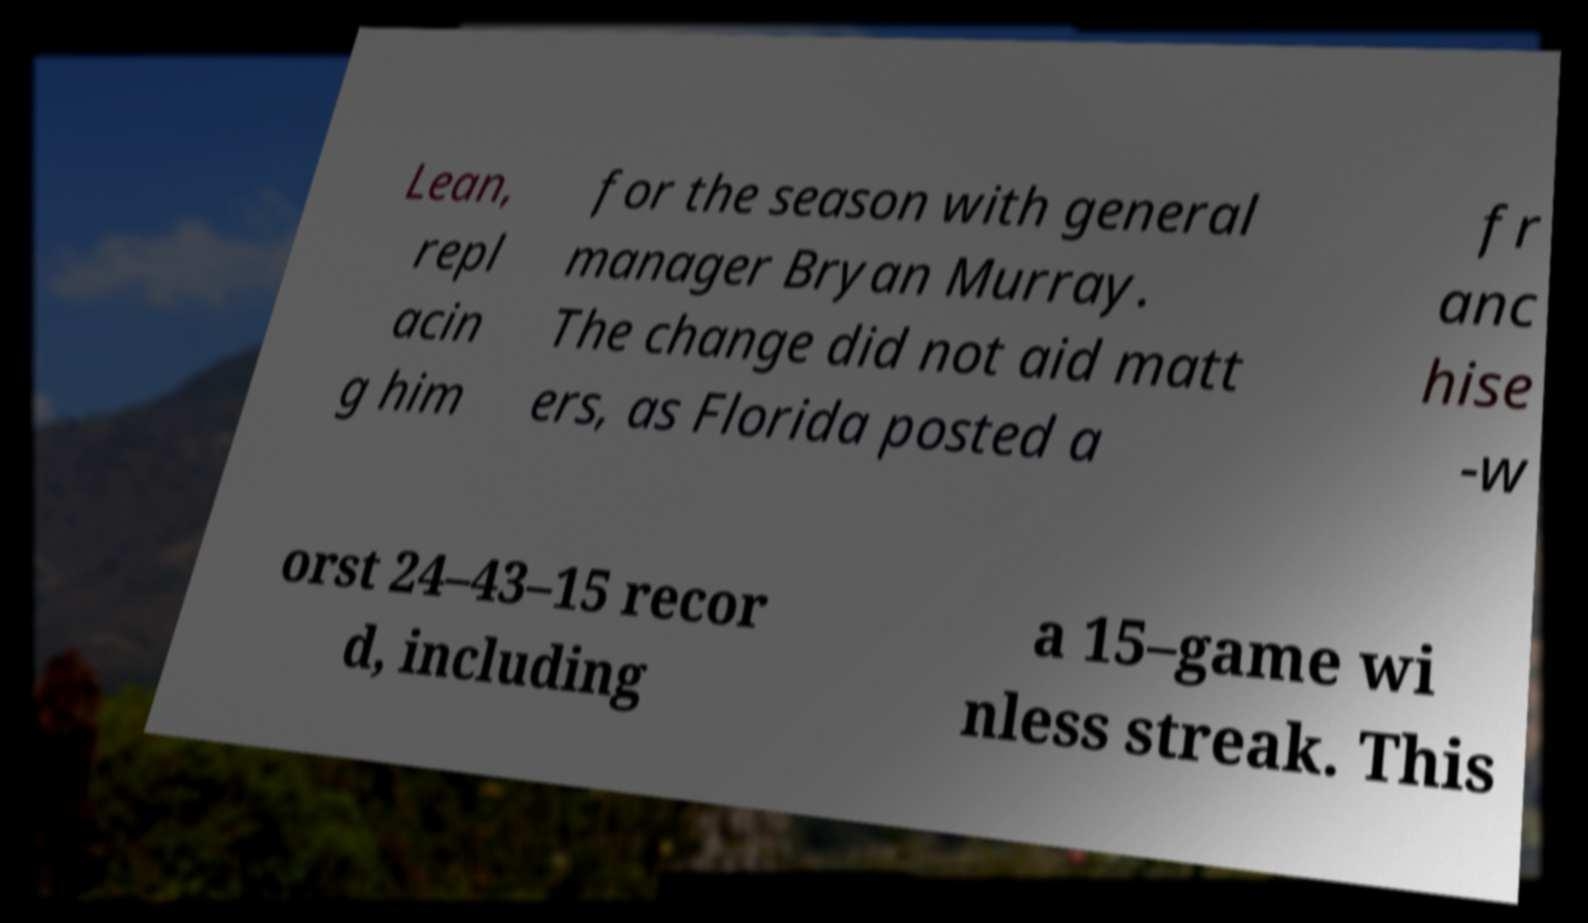Please read and relay the text visible in this image. What does it say? Lean, repl acin g him for the season with general manager Bryan Murray. The change did not aid matt ers, as Florida posted a fr anc hise -w orst 24–43–15 recor d, including a 15–game wi nless streak. This 